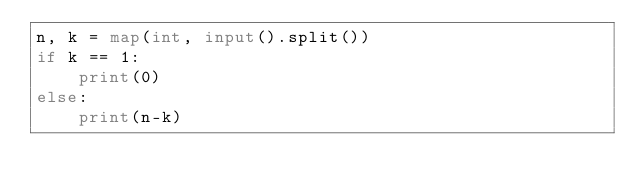Convert code to text. <code><loc_0><loc_0><loc_500><loc_500><_Python_>n, k = map(int, input().split())
if k == 1:
    print(0)
else:
    print(n-k)</code> 